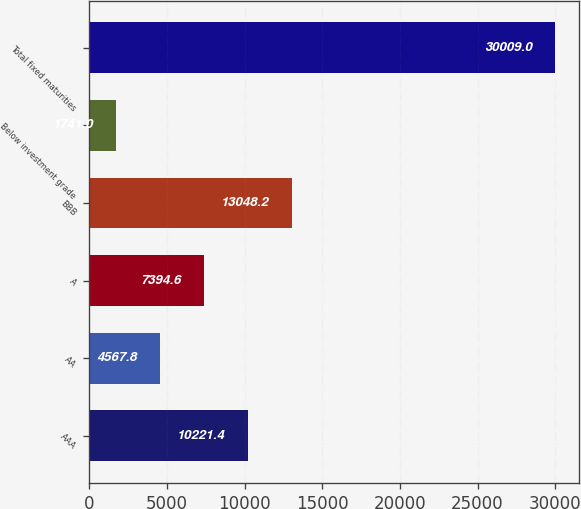<chart> <loc_0><loc_0><loc_500><loc_500><bar_chart><fcel>AAA<fcel>AA<fcel>A<fcel>BBB<fcel>Below investment grade<fcel>Total fixed maturities<nl><fcel>10221.4<fcel>4567.8<fcel>7394.6<fcel>13048.2<fcel>1741<fcel>30009<nl></chart> 